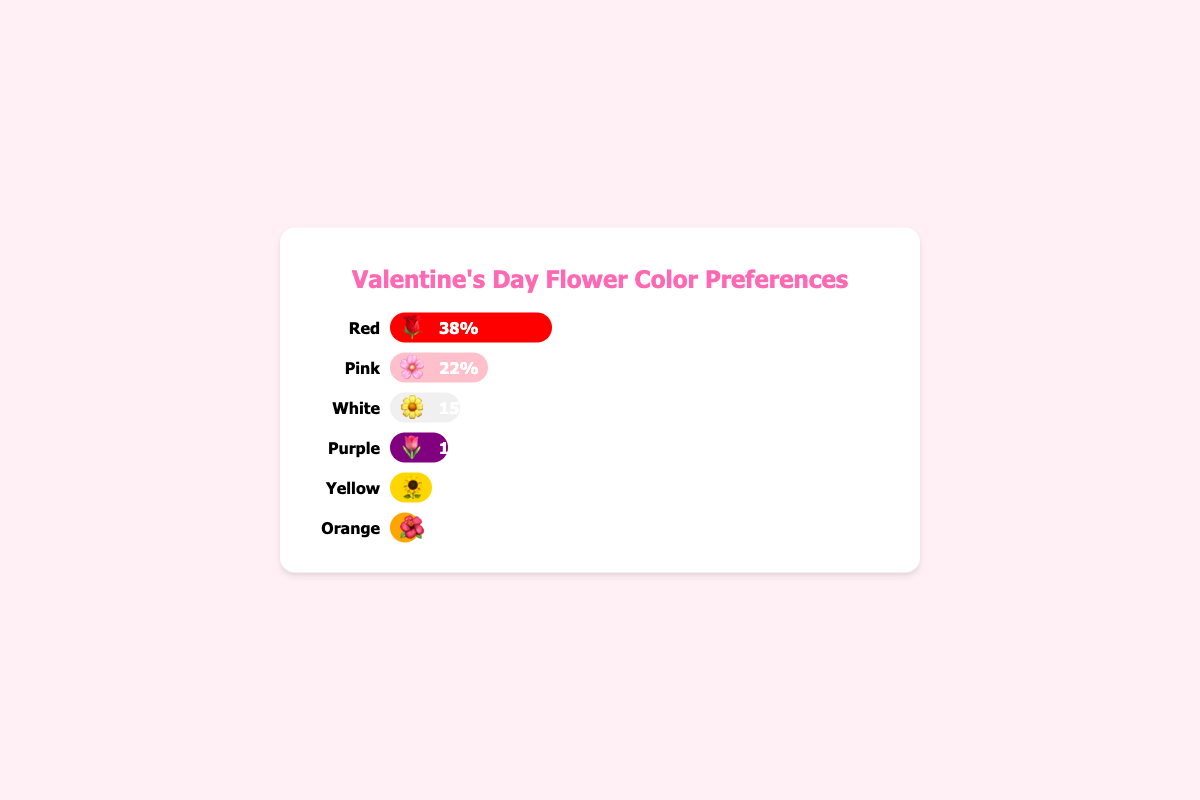What percentage of people prefer red flowers for Valentine's Day? The bar representing red flowers has an emoji 🌹 and states 38%.
Answer: 38% Which flower color is the least preferred? The bar with the lowest percentage is for orange flowers, represented with the emoji 🌺, at 5%.
Answer: Orange How many percentage points more popular are red flowers compared to yellow flowers? The percentage of red flowers is 38% and yellow flowers is 8%. Subtracting these gives 38% - 8% = 30%.
Answer: 30% What are the top three most preferred flower colors and their respective percentages? The top three longest bars are for red (38%), pink (22%), and white (15%).
Answer: Red: 38%, Pink: 22%, White: 15% If you combine the preferences for pink and purple flowers, what is the total percentage? The sum of the percentages for pink (22%) and purple (12%) flowers is 22% + 12% = 34%.
Answer: 34% Which two flower colors have a combined preference percentage of 20%? The bars for yellow (8%) and orange (5%) don't sum up to 20%, neither do any other pair combined with these. However, purple (12%) and orange (5%) sum to 17%, white (15%) and orange (5%) sum to 20%.
Answer: White and Orange Is the preference for white flowers greater than the preference for yellow and orange flowers combined? The bar for white flowers is 15%. The sum of preferences for yellow (8%) and orange (5%) flowers is 8% + 5% = 13%, which is less than 15%.
Answer: Yes Which flower color is preferred almost three times more than orange flowers? The bar for pink flowers is 22%, which is almost three times the percentage of orange flowers (5%). 5% * 3 = 15%, which is close to 22%.
Answer: Pink Among all flower color preferences, what is the difference between the highest and the lowest percentages? The highest percentage is for red flowers (38%) and the lowest is for orange flowers (5%). The difference is 38% - 5% = 33%.
Answer: 33% If a survey shows that the total percentage exceeds 100%, what would that imply about the respondents' answer choices? Survey percentages exceeding 100% would imply that respondents could select multiple answers, indicating overlapping preferences.
Answer: Multiple selections by respondents 